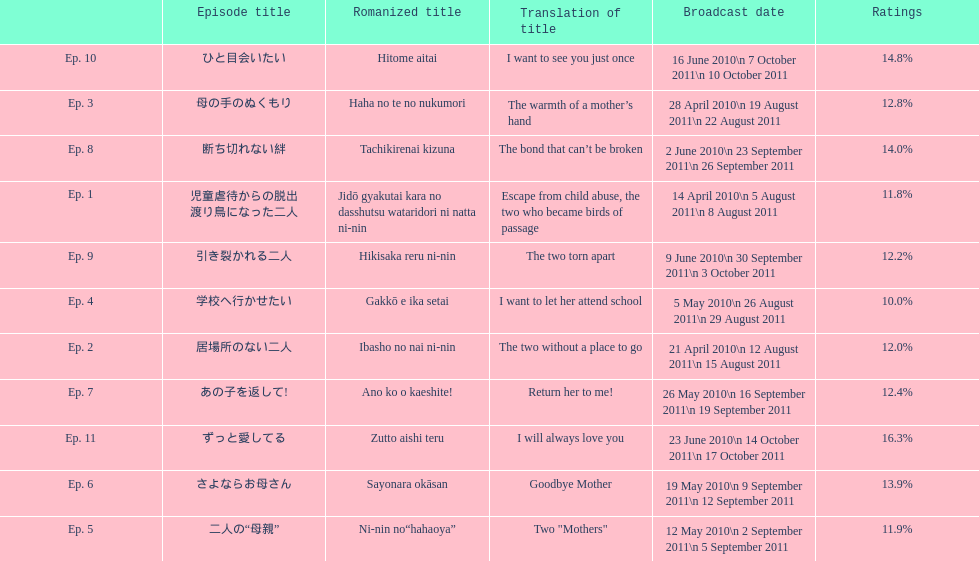How many episode are not over 14%? 8. 